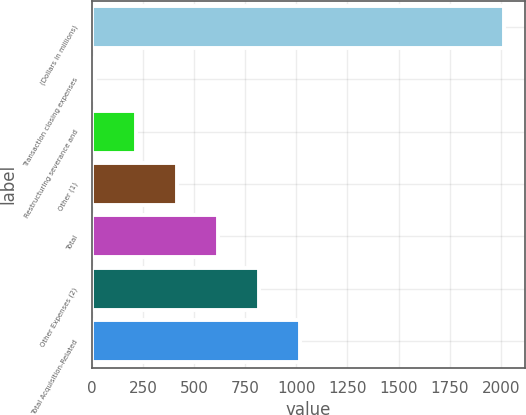<chart> <loc_0><loc_0><loc_500><loc_500><bar_chart><fcel>(Dollars in millions)<fcel>Transaction closing expenses<fcel>Restructuring severance and<fcel>Other (1)<fcel>Total<fcel>Other Expenses (2)<fcel>Total Acquisition-Related<nl><fcel>2018<fcel>15<fcel>215.3<fcel>415.6<fcel>615.9<fcel>816.2<fcel>1016.5<nl></chart> 